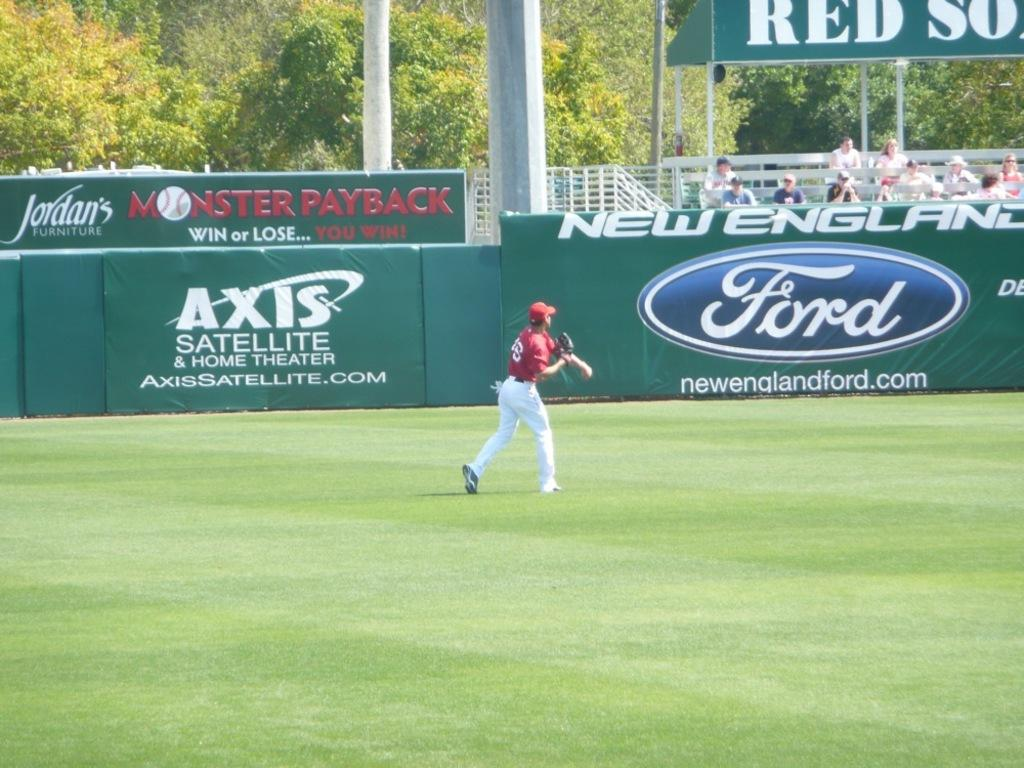<image>
Present a compact description of the photo's key features. an ad for Ford that is on the wall in the outfield 